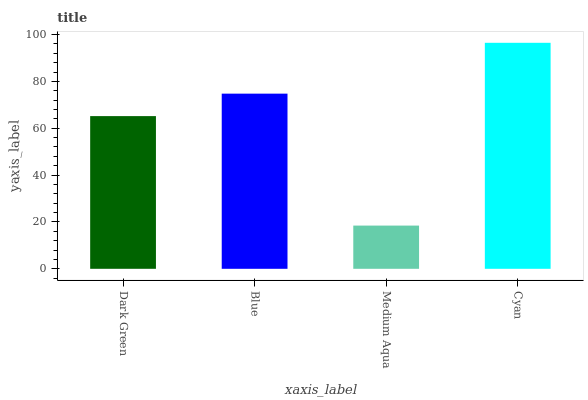Is Medium Aqua the minimum?
Answer yes or no. Yes. Is Cyan the maximum?
Answer yes or no. Yes. Is Blue the minimum?
Answer yes or no. No. Is Blue the maximum?
Answer yes or no. No. Is Blue greater than Dark Green?
Answer yes or no. Yes. Is Dark Green less than Blue?
Answer yes or no. Yes. Is Dark Green greater than Blue?
Answer yes or no. No. Is Blue less than Dark Green?
Answer yes or no. No. Is Blue the high median?
Answer yes or no. Yes. Is Dark Green the low median?
Answer yes or no. Yes. Is Dark Green the high median?
Answer yes or no. No. Is Blue the low median?
Answer yes or no. No. 